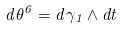<formula> <loc_0><loc_0><loc_500><loc_500>d \theta ^ { 6 } = d \gamma _ { 1 } \wedge d t</formula> 